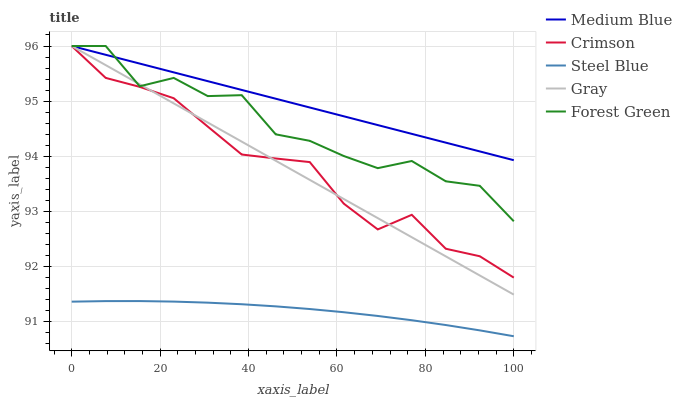Does Steel Blue have the minimum area under the curve?
Answer yes or no. Yes. Does Medium Blue have the maximum area under the curve?
Answer yes or no. Yes. Does Gray have the minimum area under the curve?
Answer yes or no. No. Does Gray have the maximum area under the curve?
Answer yes or no. No. Is Medium Blue the smoothest?
Answer yes or no. Yes. Is Forest Green the roughest?
Answer yes or no. Yes. Is Gray the smoothest?
Answer yes or no. No. Is Gray the roughest?
Answer yes or no. No. Does Gray have the lowest value?
Answer yes or no. No. Does Medium Blue have the highest value?
Answer yes or no. Yes. Does Steel Blue have the highest value?
Answer yes or no. No. Is Steel Blue less than Medium Blue?
Answer yes or no. Yes. Is Crimson greater than Steel Blue?
Answer yes or no. Yes. Does Gray intersect Medium Blue?
Answer yes or no. Yes. Is Gray less than Medium Blue?
Answer yes or no. No. Is Gray greater than Medium Blue?
Answer yes or no. No. Does Steel Blue intersect Medium Blue?
Answer yes or no. No. 